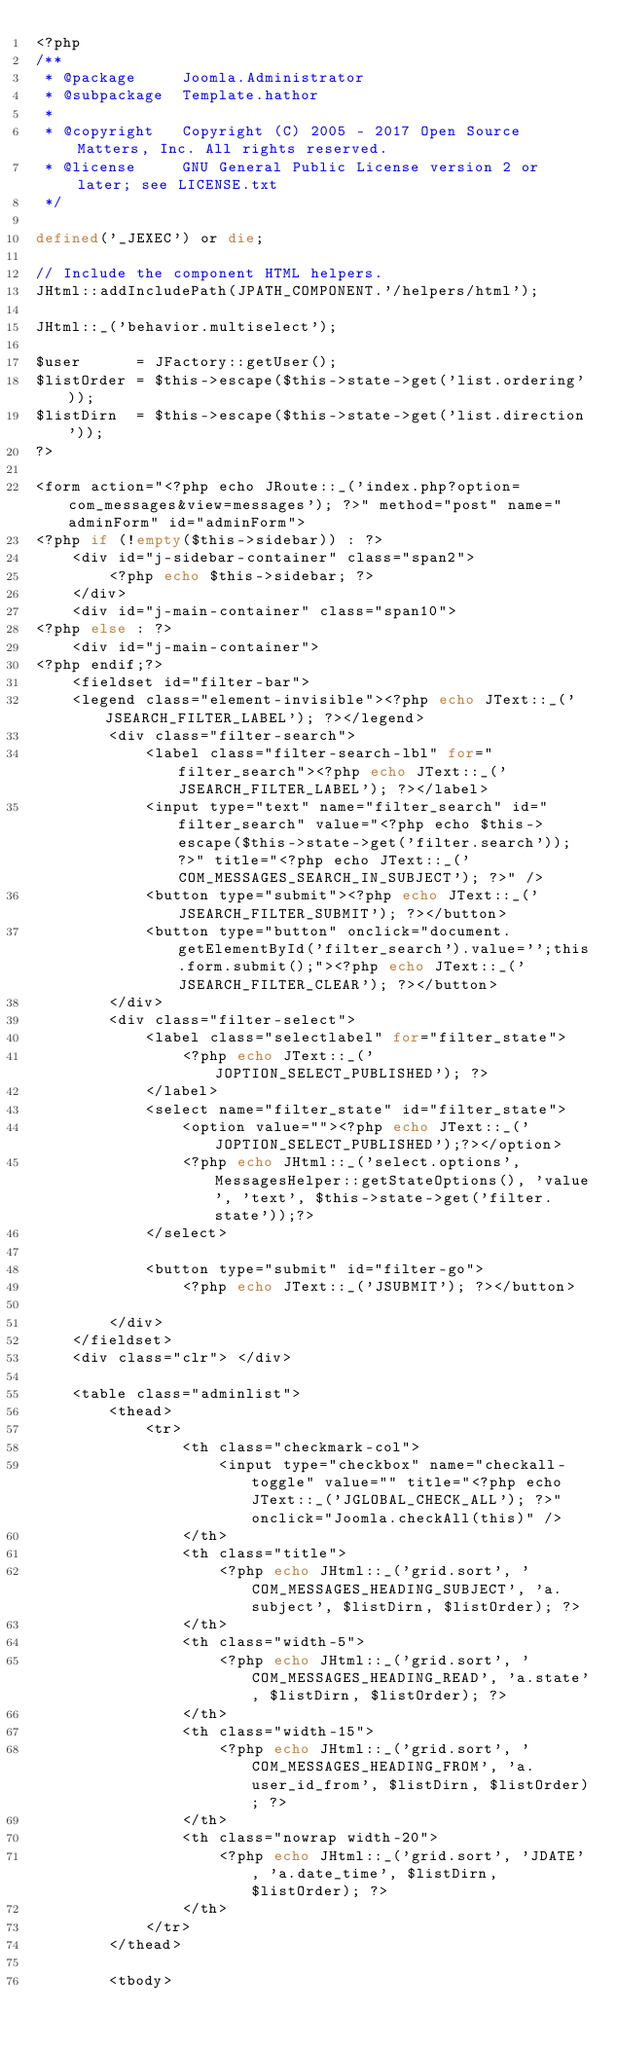Convert code to text. <code><loc_0><loc_0><loc_500><loc_500><_PHP_><?php
/**
 * @package     Joomla.Administrator
 * @subpackage  Template.hathor
 *
 * @copyright   Copyright (C) 2005 - 2017 Open Source Matters, Inc. All rights reserved.
 * @license     GNU General Public License version 2 or later; see LICENSE.txt
 */

defined('_JEXEC') or die;

// Include the component HTML helpers.
JHtml::addIncludePath(JPATH_COMPONENT.'/helpers/html');

JHtml::_('behavior.multiselect');

$user      = JFactory::getUser();
$listOrder = $this->escape($this->state->get('list.ordering'));
$listDirn  = $this->escape($this->state->get('list.direction'));
?>

<form action="<?php echo JRoute::_('index.php?option=com_messages&view=messages'); ?>" method="post" name="adminForm" id="adminForm">
<?php if (!empty($this->sidebar)) : ?>
	<div id="j-sidebar-container" class="span2">
		<?php echo $this->sidebar; ?>
	</div>
	<div id="j-main-container" class="span10">
<?php else : ?>
	<div id="j-main-container">
<?php endif;?>
	<fieldset id="filter-bar">
	<legend class="element-invisible"><?php echo JText::_('JSEARCH_FILTER_LABEL'); ?></legend>
		<div class="filter-search">
			<label class="filter-search-lbl" for="filter_search"><?php echo JText::_('JSEARCH_FILTER_LABEL'); ?></label>
			<input type="text" name="filter_search" id="filter_search" value="<?php echo $this->escape($this->state->get('filter.search')); ?>" title="<?php echo JText::_('COM_MESSAGES_SEARCH_IN_SUBJECT'); ?>" />
			<button type="submit"><?php echo JText::_('JSEARCH_FILTER_SUBMIT'); ?></button>
			<button type="button" onclick="document.getElementById('filter_search').value='';this.form.submit();"><?php echo JText::_('JSEARCH_FILTER_CLEAR'); ?></button>
		</div>
		<div class="filter-select">
			<label class="selectlabel" for="filter_state">
				<?php echo JText::_('JOPTION_SELECT_PUBLISHED'); ?>
			</label>
			<select name="filter_state" id="filter_state">
				<option value=""><?php echo JText::_('JOPTION_SELECT_PUBLISHED');?></option>
				<?php echo JHtml::_('select.options', MessagesHelper::getStateOptions(), 'value', 'text', $this->state->get('filter.state'));?>
			</select>

			<button type="submit" id="filter-go">
				<?php echo JText::_('JSUBMIT'); ?></button>

		</div>
	</fieldset>
	<div class="clr"> </div>

	<table class="adminlist">
		<thead>
			<tr>
				<th class="checkmark-col">
					<input type="checkbox" name="checkall-toggle" value="" title="<?php echo JText::_('JGLOBAL_CHECK_ALL'); ?>" onclick="Joomla.checkAll(this)" />
				</th>
				<th class="title">
					<?php echo JHtml::_('grid.sort', 'COM_MESSAGES_HEADING_SUBJECT', 'a.subject', $listDirn, $listOrder); ?>
				</th>
				<th class="width-5">
					<?php echo JHtml::_('grid.sort', 'COM_MESSAGES_HEADING_READ', 'a.state', $listDirn, $listOrder); ?>
				</th>
				<th class="width-15">
					<?php echo JHtml::_('grid.sort', 'COM_MESSAGES_HEADING_FROM', 'a.user_id_from', $listDirn, $listOrder); ?>
				</th>
				<th class="nowrap width-20">
					<?php echo JHtml::_('grid.sort', 'JDATE', 'a.date_time', $listDirn, $listOrder); ?>
				</th>
			</tr>
		</thead>

		<tbody></code> 